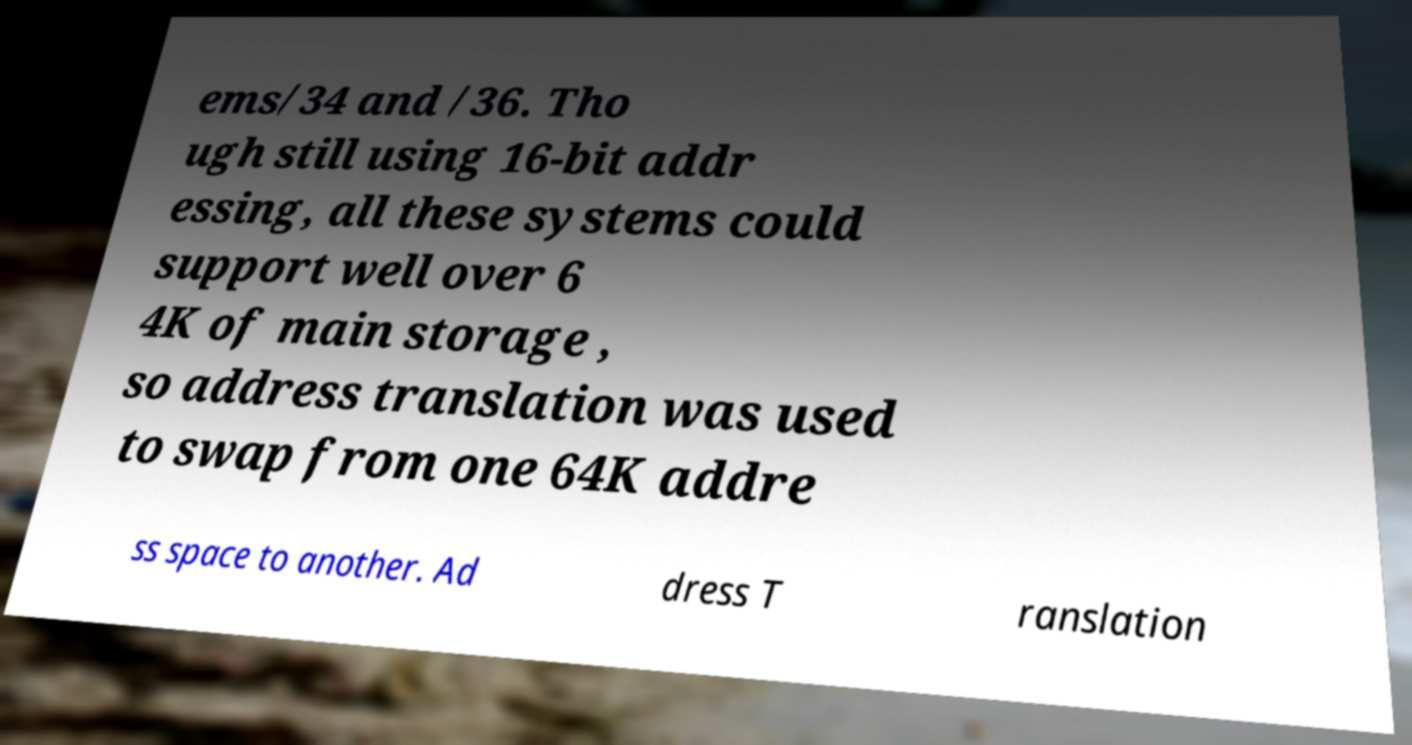Please read and relay the text visible in this image. What does it say? ems/34 and /36. Tho ugh still using 16-bit addr essing, all these systems could support well over 6 4K of main storage , so address translation was used to swap from one 64K addre ss space to another. Ad dress T ranslation 